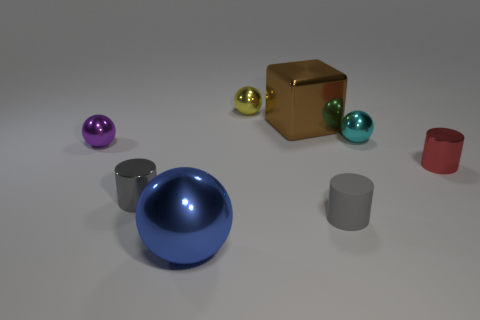Add 1 gray metallic cylinders. How many objects exist? 9 Subtract all gray cylinders. How many cylinders are left? 1 Subtract all large shiny balls. How many balls are left? 3 Subtract all cubes. How many objects are left? 7 Add 1 small red metal things. How many small red metal things are left? 2 Add 5 big blue matte objects. How many big blue matte objects exist? 5 Subtract 1 yellow balls. How many objects are left? 7 Subtract 1 balls. How many balls are left? 3 Subtract all purple balls. Subtract all gray cylinders. How many balls are left? 3 Subtract all red cylinders. How many gray balls are left? 0 